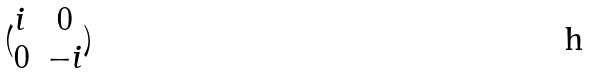<formula> <loc_0><loc_0><loc_500><loc_500>( \begin{matrix} i & 0 \\ 0 & - i \end{matrix} )</formula> 